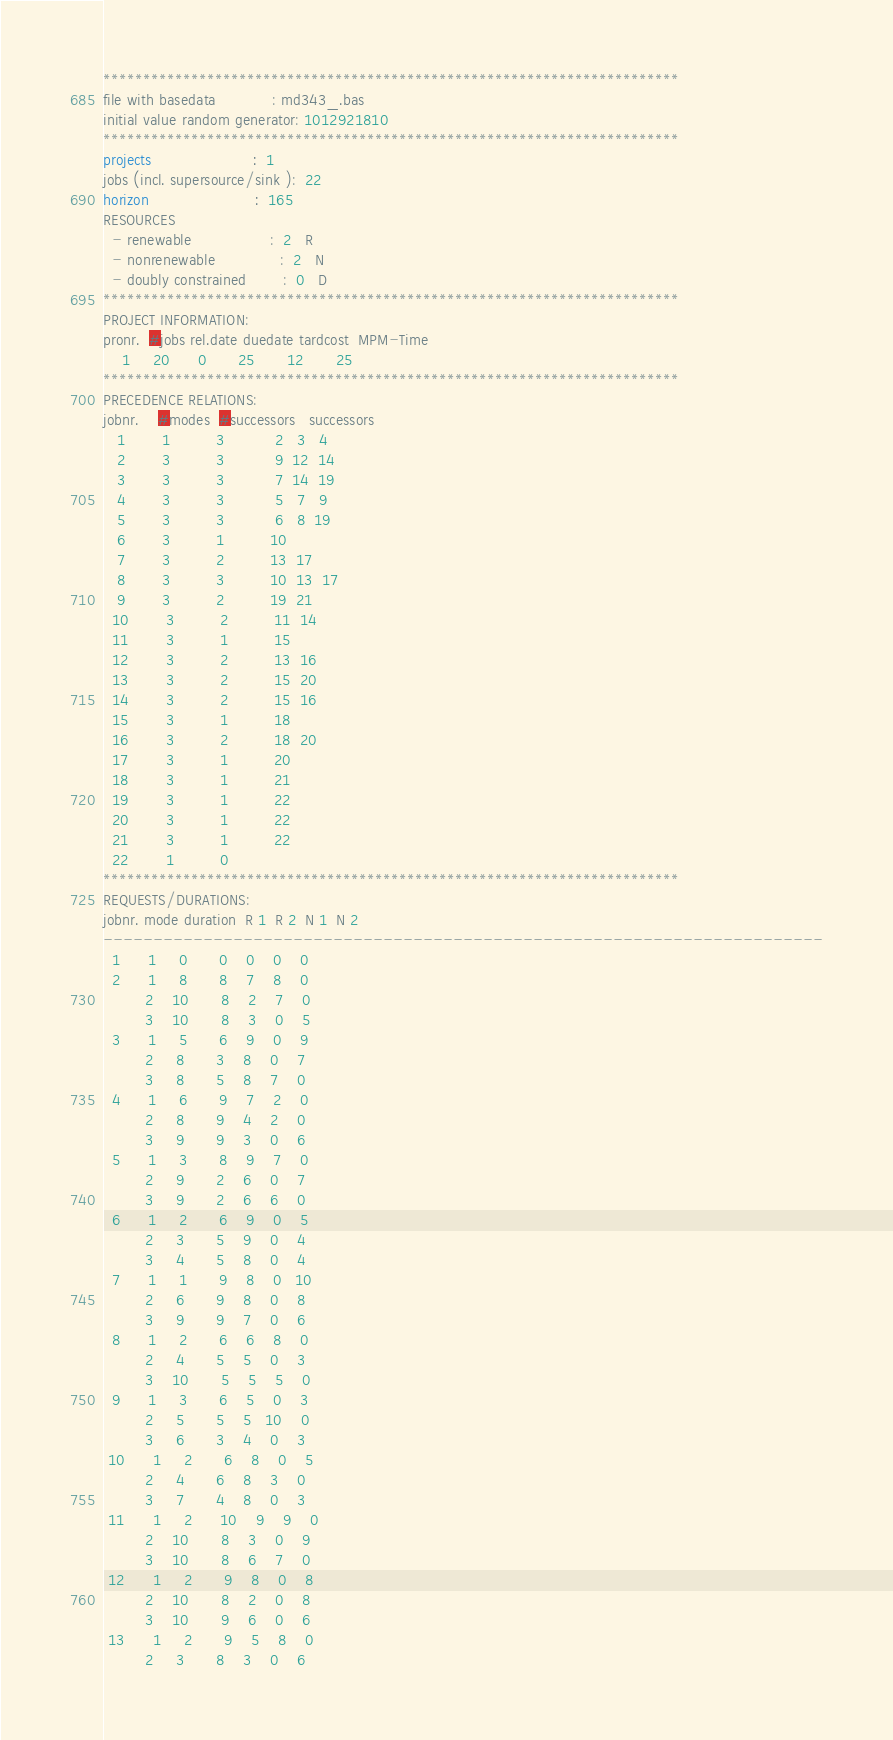Convert code to text. <code><loc_0><loc_0><loc_500><loc_500><_ObjectiveC_>************************************************************************
file with basedata            : md343_.bas
initial value random generator: 1012921810
************************************************************************
projects                      :  1
jobs (incl. supersource/sink ):  22
horizon                       :  165
RESOURCES
  - renewable                 :  2   R
  - nonrenewable              :  2   N
  - doubly constrained        :  0   D
************************************************************************
PROJECT INFORMATION:
pronr.  #jobs rel.date duedate tardcost  MPM-Time
    1     20      0       25       12       25
************************************************************************
PRECEDENCE RELATIONS:
jobnr.    #modes  #successors   successors
   1        1          3           2   3   4
   2        3          3           9  12  14
   3        3          3           7  14  19
   4        3          3           5   7   9
   5        3          3           6   8  19
   6        3          1          10
   7        3          2          13  17
   8        3          3          10  13  17
   9        3          2          19  21
  10        3          2          11  14
  11        3          1          15
  12        3          2          13  16
  13        3          2          15  20
  14        3          2          15  16
  15        3          1          18
  16        3          2          18  20
  17        3          1          20
  18        3          1          21
  19        3          1          22
  20        3          1          22
  21        3          1          22
  22        1          0        
************************************************************************
REQUESTS/DURATIONS:
jobnr. mode duration  R 1  R 2  N 1  N 2
------------------------------------------------------------------------
  1      1     0       0    0    0    0
  2      1     8       8    7    8    0
         2    10       8    2    7    0
         3    10       8    3    0    5
  3      1     5       6    9    0    9
         2     8       3    8    0    7
         3     8       5    8    7    0
  4      1     6       9    7    2    0
         2     8       9    4    2    0
         3     9       9    3    0    6
  5      1     3       8    9    7    0
         2     9       2    6    0    7
         3     9       2    6    6    0
  6      1     2       6    9    0    5
         2     3       5    9    0    4
         3     4       5    8    0    4
  7      1     1       9    8    0   10
         2     6       9    8    0    8
         3     9       9    7    0    6
  8      1     2       6    6    8    0
         2     4       5    5    0    3
         3    10       5    5    5    0
  9      1     3       6    5    0    3
         2     5       5    5   10    0
         3     6       3    4    0    3
 10      1     2       6    8    0    5
         2     4       6    8    3    0
         3     7       4    8    0    3
 11      1     2      10    9    9    0
         2    10       8    3    0    9
         3    10       8    6    7    0
 12      1     2       9    8    0    8
         2    10       8    2    0    8
         3    10       9    6    0    6
 13      1     2       9    5    8    0
         2     3       8    3    0    6</code> 